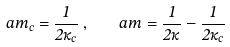<formula> <loc_0><loc_0><loc_500><loc_500>a m _ { c } = \frac { 1 } { 2 \kappa _ { c } } \, , \quad a m = \frac { 1 } { 2 \kappa } - \frac { 1 } { 2 \kappa _ { c } } \,</formula> 